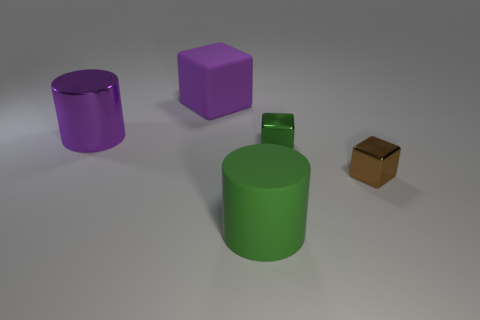Do the metal cylinder and the big cube have the same color?
Your answer should be compact. Yes. Is there a matte cylinder of the same color as the large shiny cylinder?
Your answer should be compact. No. Do the tiny object that is right of the green cube and the big block that is behind the green rubber thing have the same material?
Offer a terse response. No. What is the color of the big block?
Your answer should be compact. Purple. What size is the matte object that is behind the green thing in front of the tiny cube left of the small brown metal object?
Make the answer very short. Large. How many other things are the same size as the purple cylinder?
Provide a short and direct response. 2. What number of green cubes are the same material as the tiny green thing?
Keep it short and to the point. 0. What shape is the small shiny thing in front of the small green cube?
Your response must be concise. Cube. Is the small brown thing made of the same material as the tiny thing behind the tiny brown thing?
Offer a terse response. Yes. Are any green blocks visible?
Offer a very short reply. Yes. 